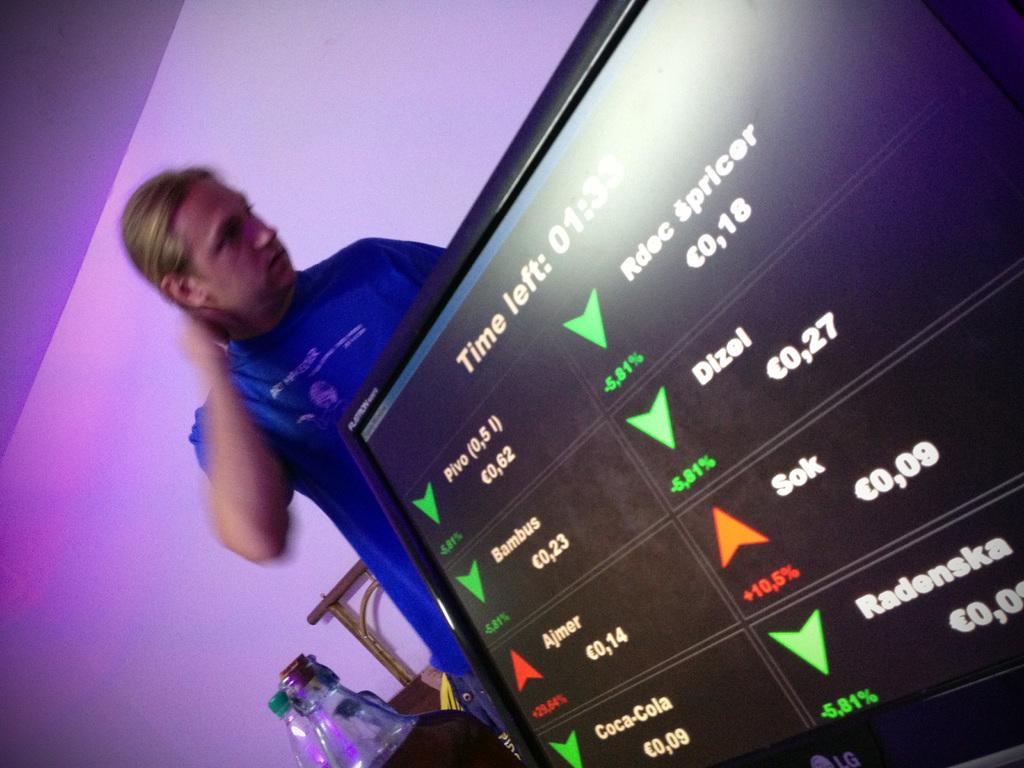Provide a one-sentence caption for the provided image. A man stands behind a display that shows there is 1:33 time remaining. 